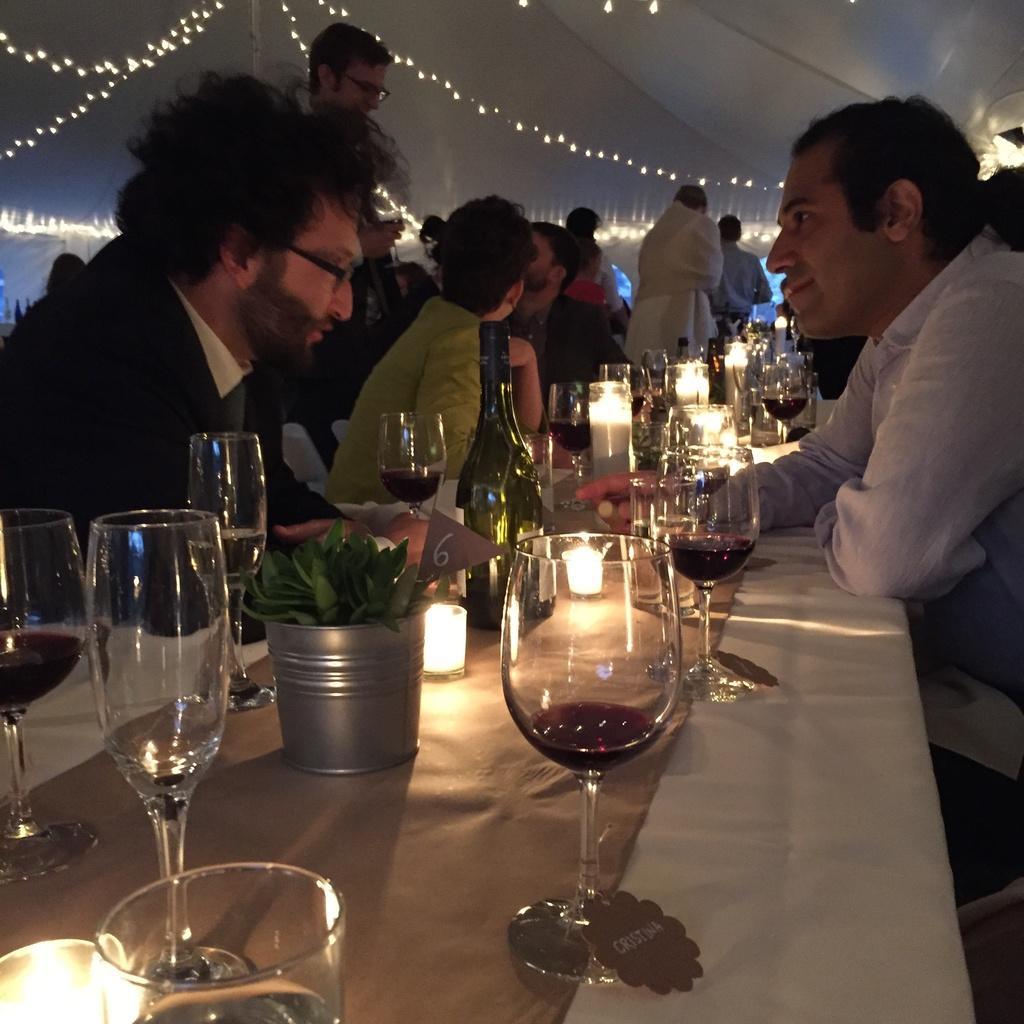Describe this image in one or two sentences. In the center of the image we can see the table. On the table we can see the glasses, pot, plant, candle lights, a bottle and some other objects. Beside the table, we can see some people are sitting on the chairs and some of them are standing. At the top of the image we can see the floor and lights. 